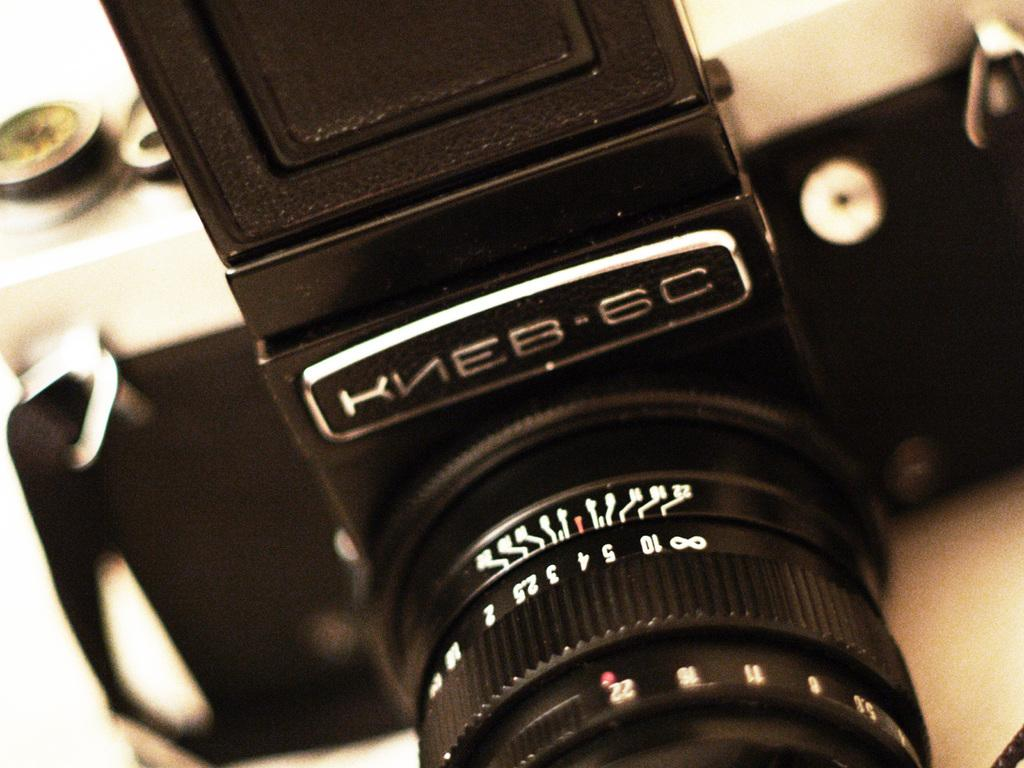What is the main subject of the image? The main subject of the image is a camera. Where is the camera located in the image? The camera is in the center of the image. What type of tent can be seen in the background of the image? There is no tent present in the image; it only features a camera in the center. What is the man cooking in the image? There is no man or cooking activity present in the image; it only features a camera in the center. 